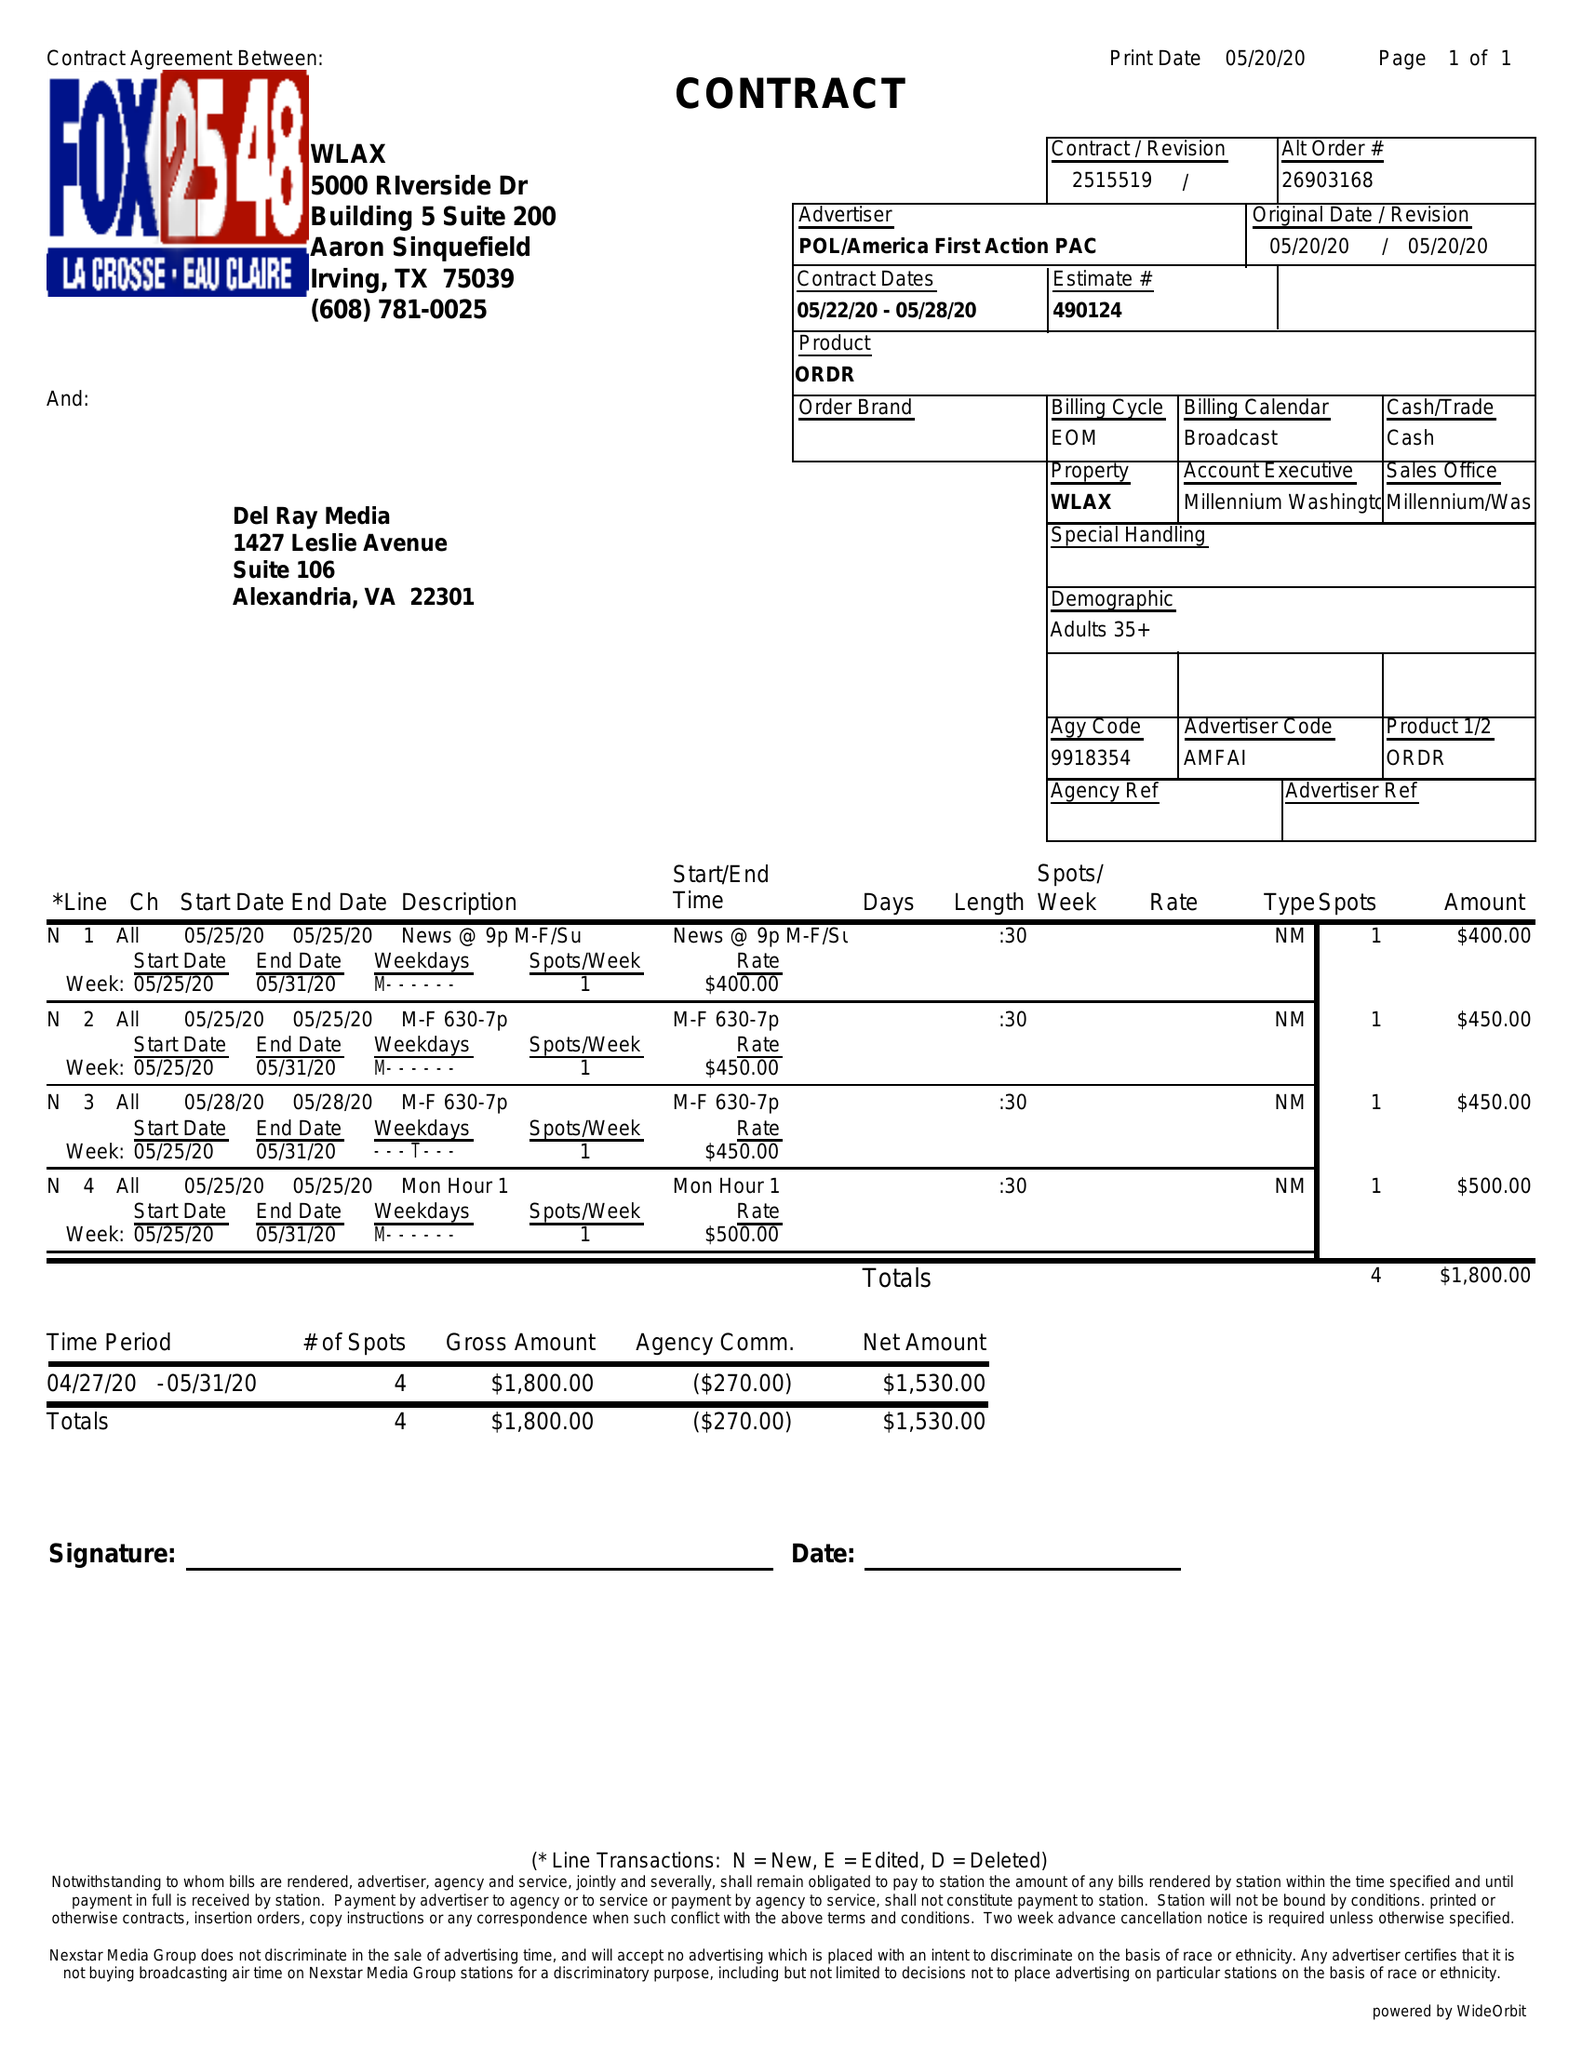What is the value for the flight_from?
Answer the question using a single word or phrase. 05/22/20 